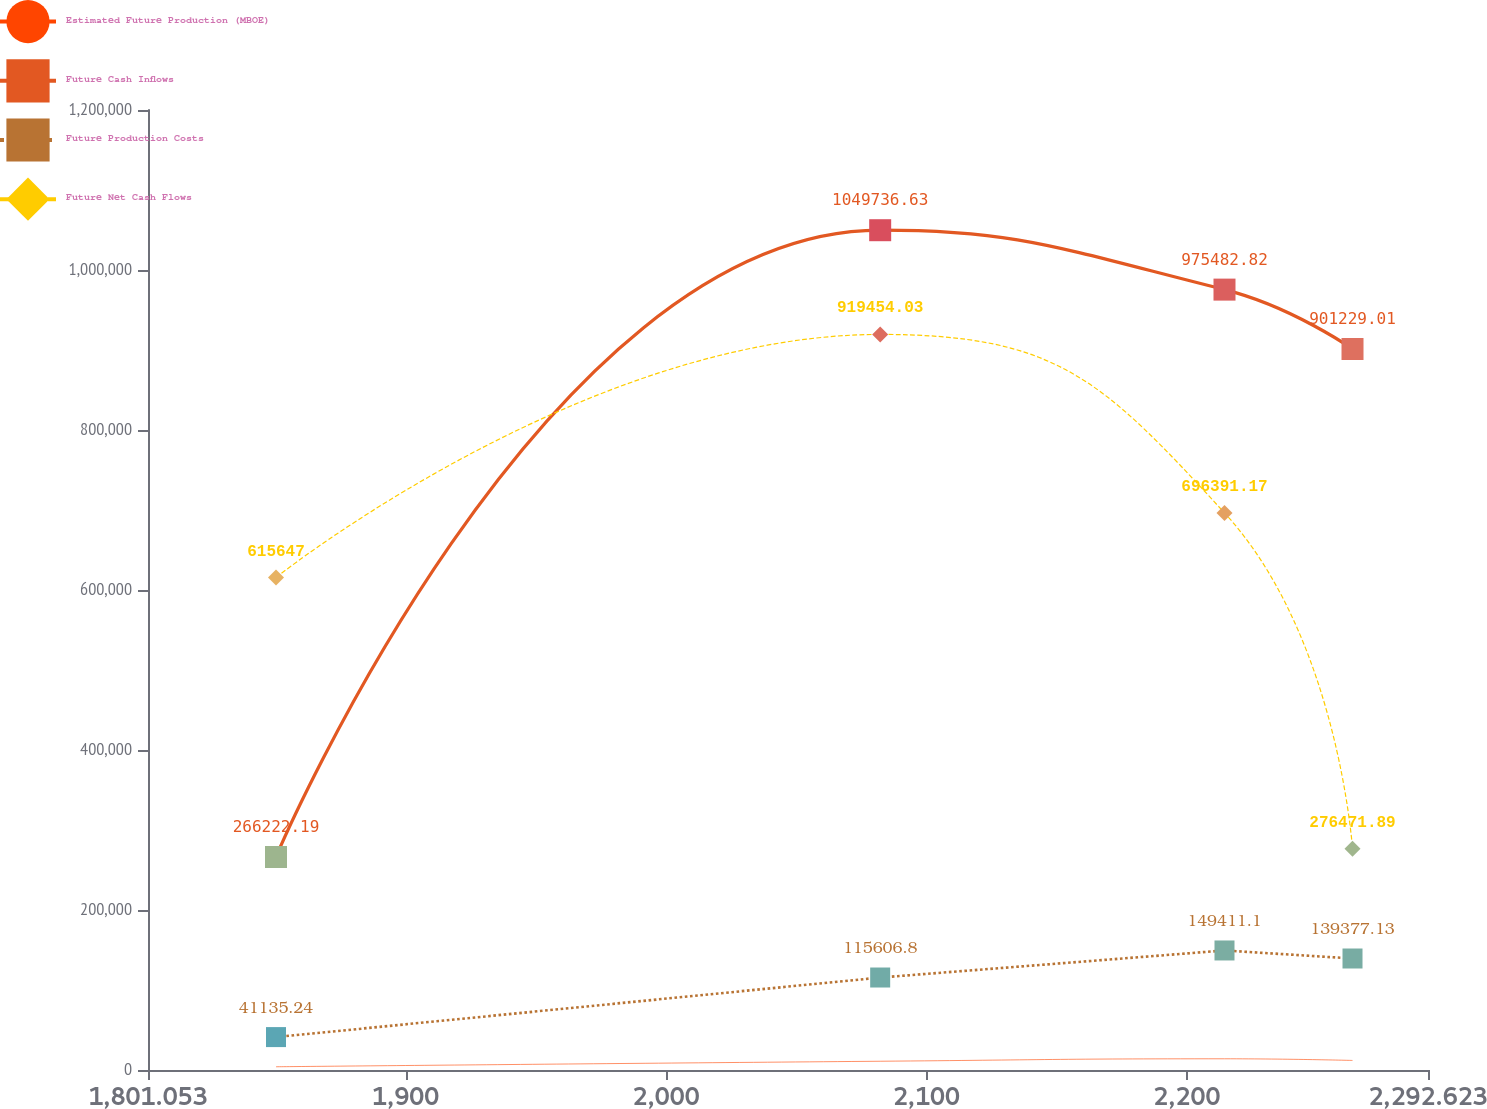<chart> <loc_0><loc_0><loc_500><loc_500><line_chart><ecel><fcel>Estimated Future Production (MBOE)<fcel>Future Cash Inflows<fcel>Future Production Costs<fcel>Future Net Cash Flows<nl><fcel>1850.21<fcel>4049.21<fcel>266222<fcel>41135.2<fcel>615647<nl><fcel>2082.24<fcel>10946.4<fcel>1.04974e+06<fcel>115607<fcel>919454<nl><fcel>2214.47<fcel>14013.5<fcel>975483<fcel>149411<fcel>696391<nl><fcel>2263.63<fcel>11942.9<fcel>901229<fcel>139377<fcel>276472<nl><fcel>2341.78<fcel>8850.11<fcel>648135<fcel>129343<fcel>112012<nl></chart> 